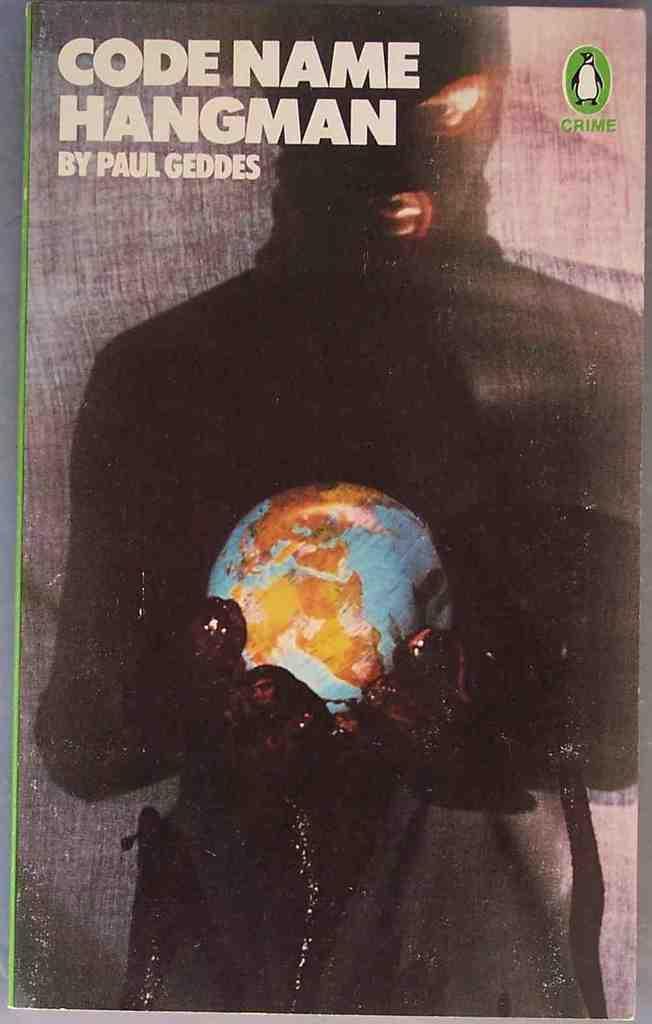Describe this image in one or two sentences. In this image there is a poster, on that poster there is a man holding a globe in his hand, in the top left there is text, in the top right there is a penguin. 